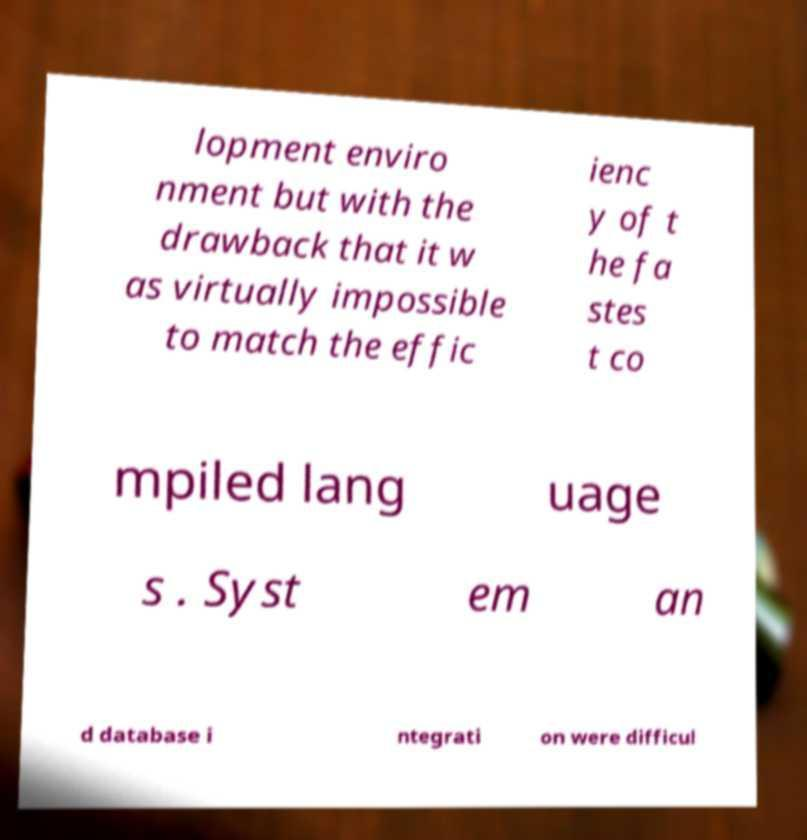What messages or text are displayed in this image? I need them in a readable, typed format. lopment enviro nment but with the drawback that it w as virtually impossible to match the effic ienc y of t he fa stes t co mpiled lang uage s . Syst em an d database i ntegrati on were difficul 